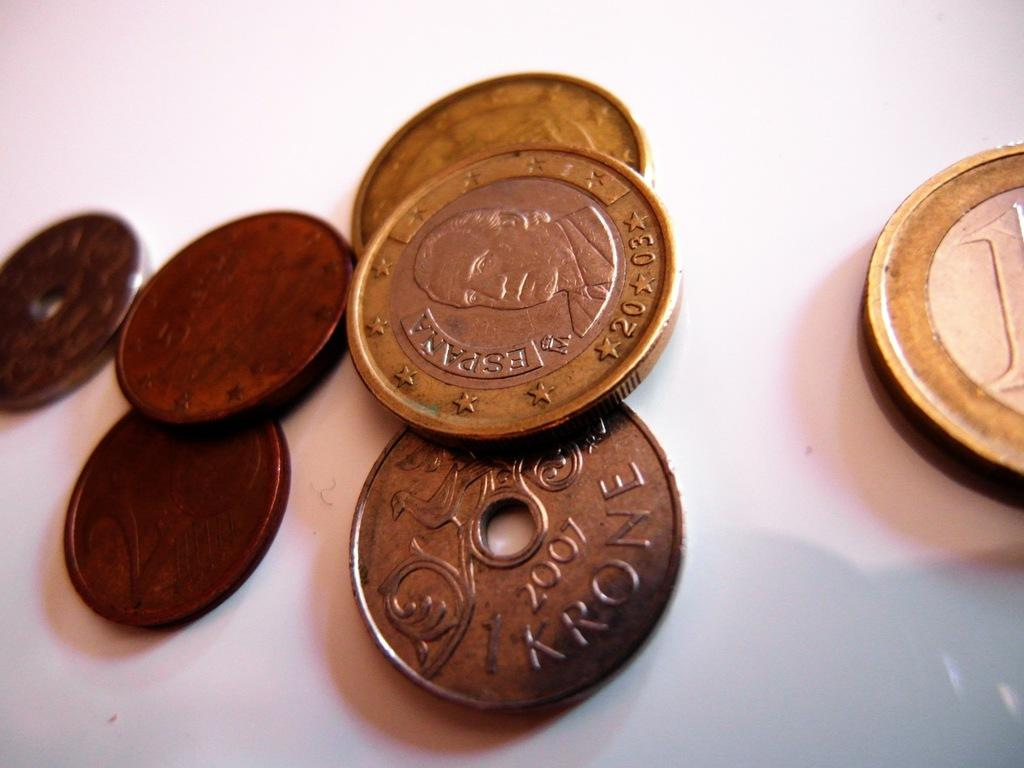Provide a one-sentence caption for the provided image. A number of coins from different countries including Spain. 